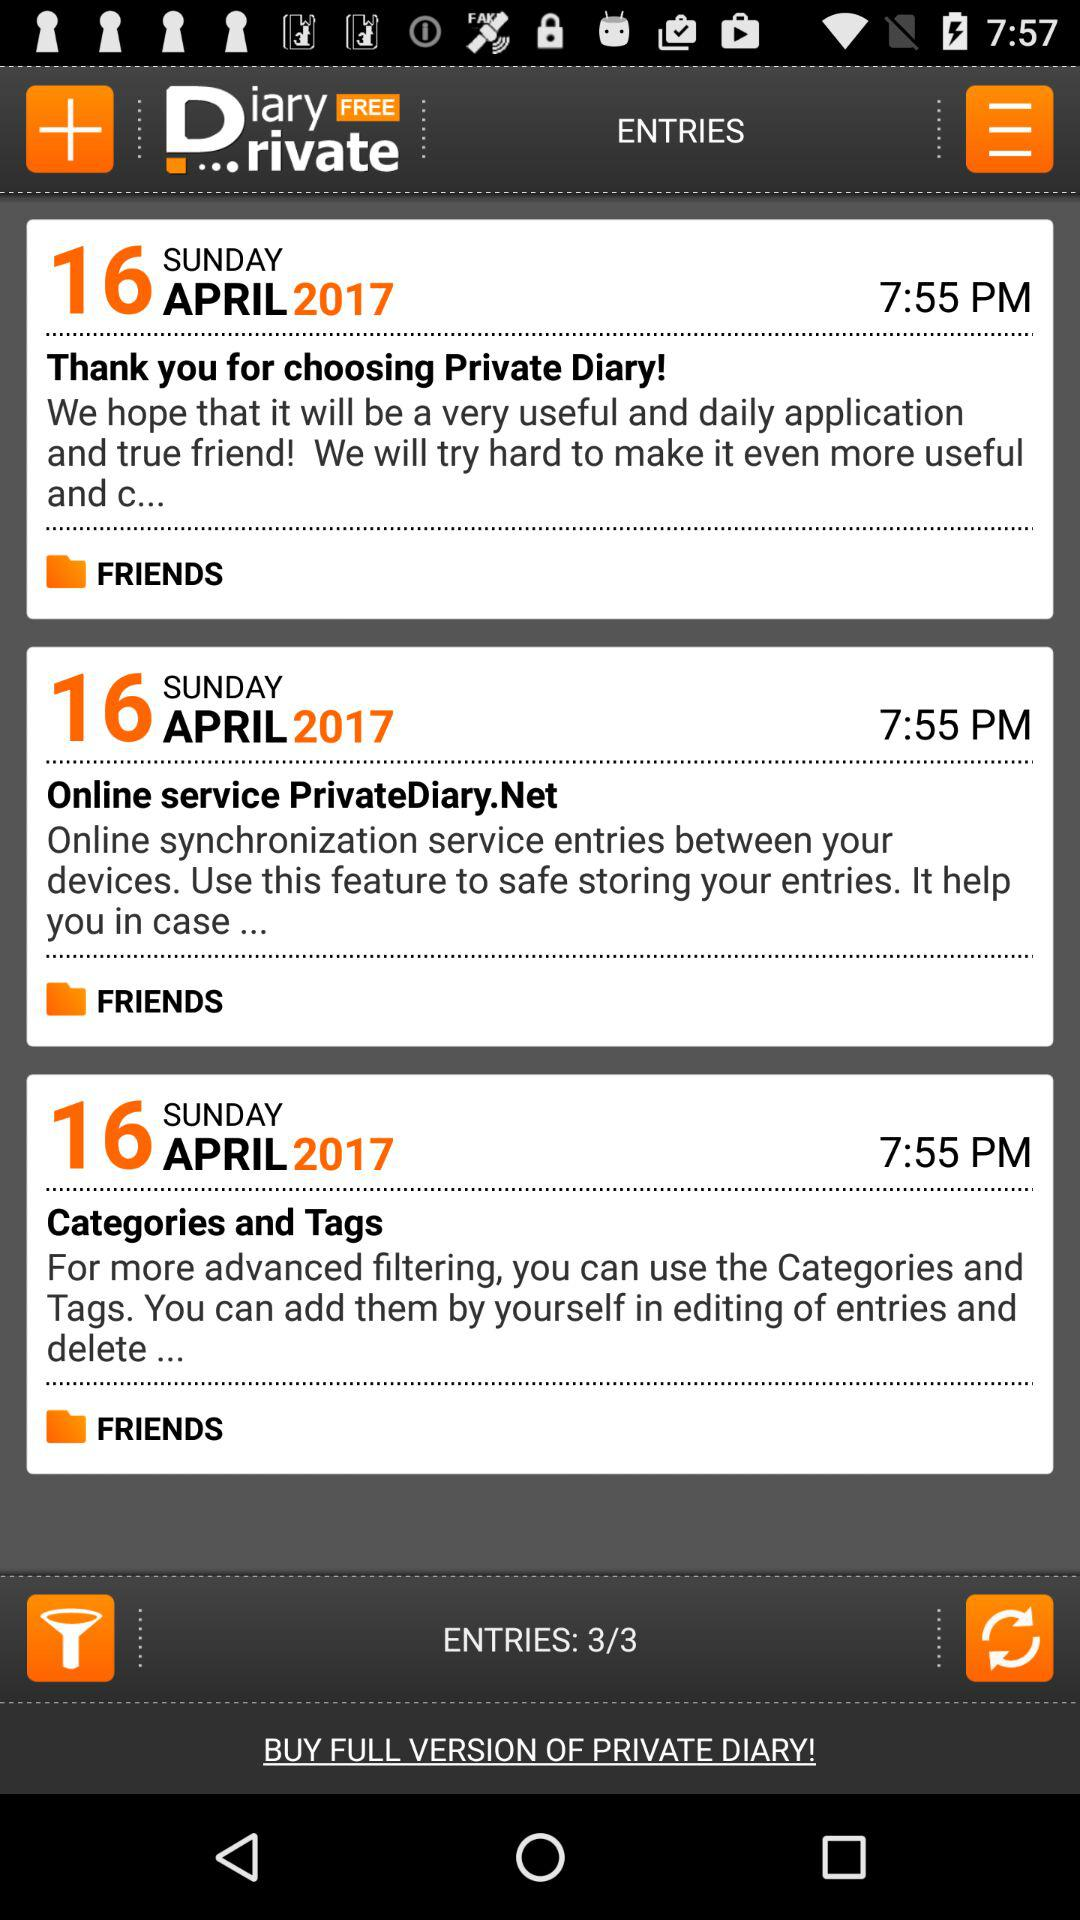What is the total number of entries? The total number of entries is 3. 